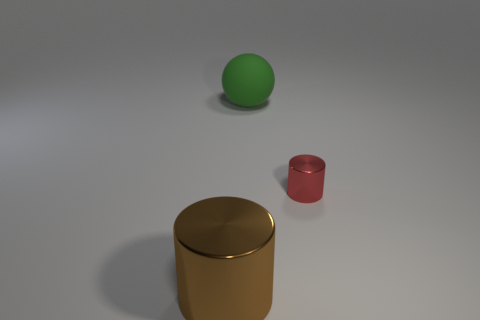What could be the purpose of these objects? While their purpose isn't explicitly clear, these objects might serve as simplistic representations used in a 3D modeling software tutorial, focused on teaching various techniques such as lighting, shading, and rendering. Each object's different shape and color could aim to demonstrate how these factors interact in a virtual environment. 